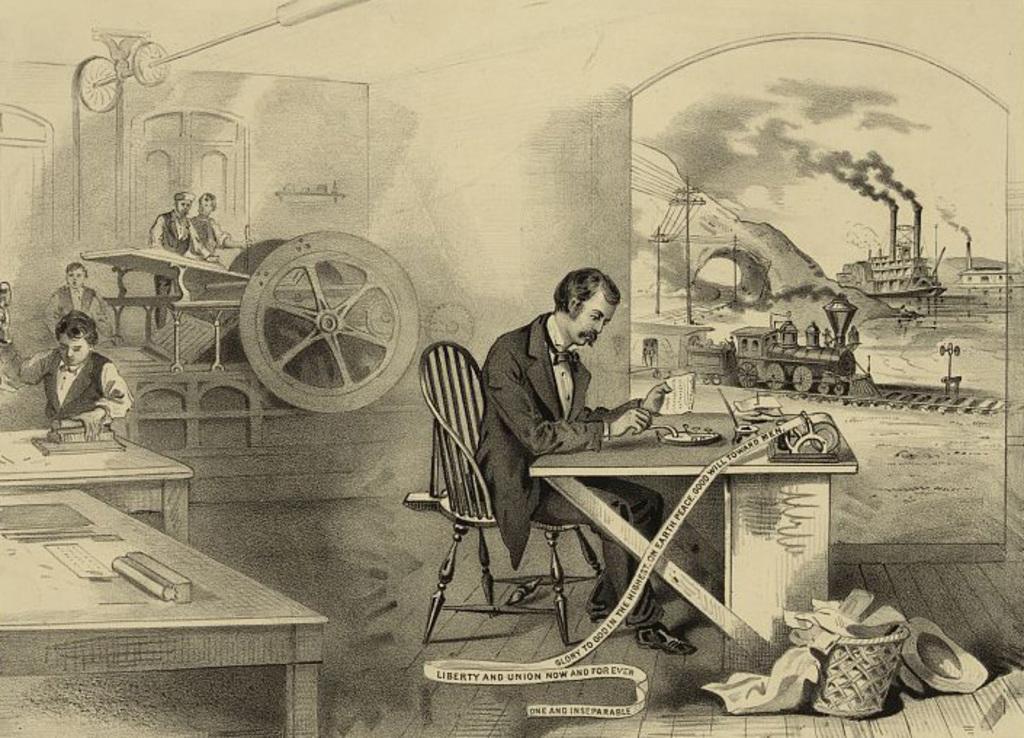Could you give a brief overview of what you see in this image? This is a black and white image seems to be an edited image. On the right there is a person wearing suit, sitting on the chair and seems to be working and there are some items placed on the top on the tables and there are some items placed on the ground. On the left we can see the group of persons and an object seems to be the cart wheel. In the background we can see the train seems to be running on the railway track and we can see the sky, smoke and some other objects. 